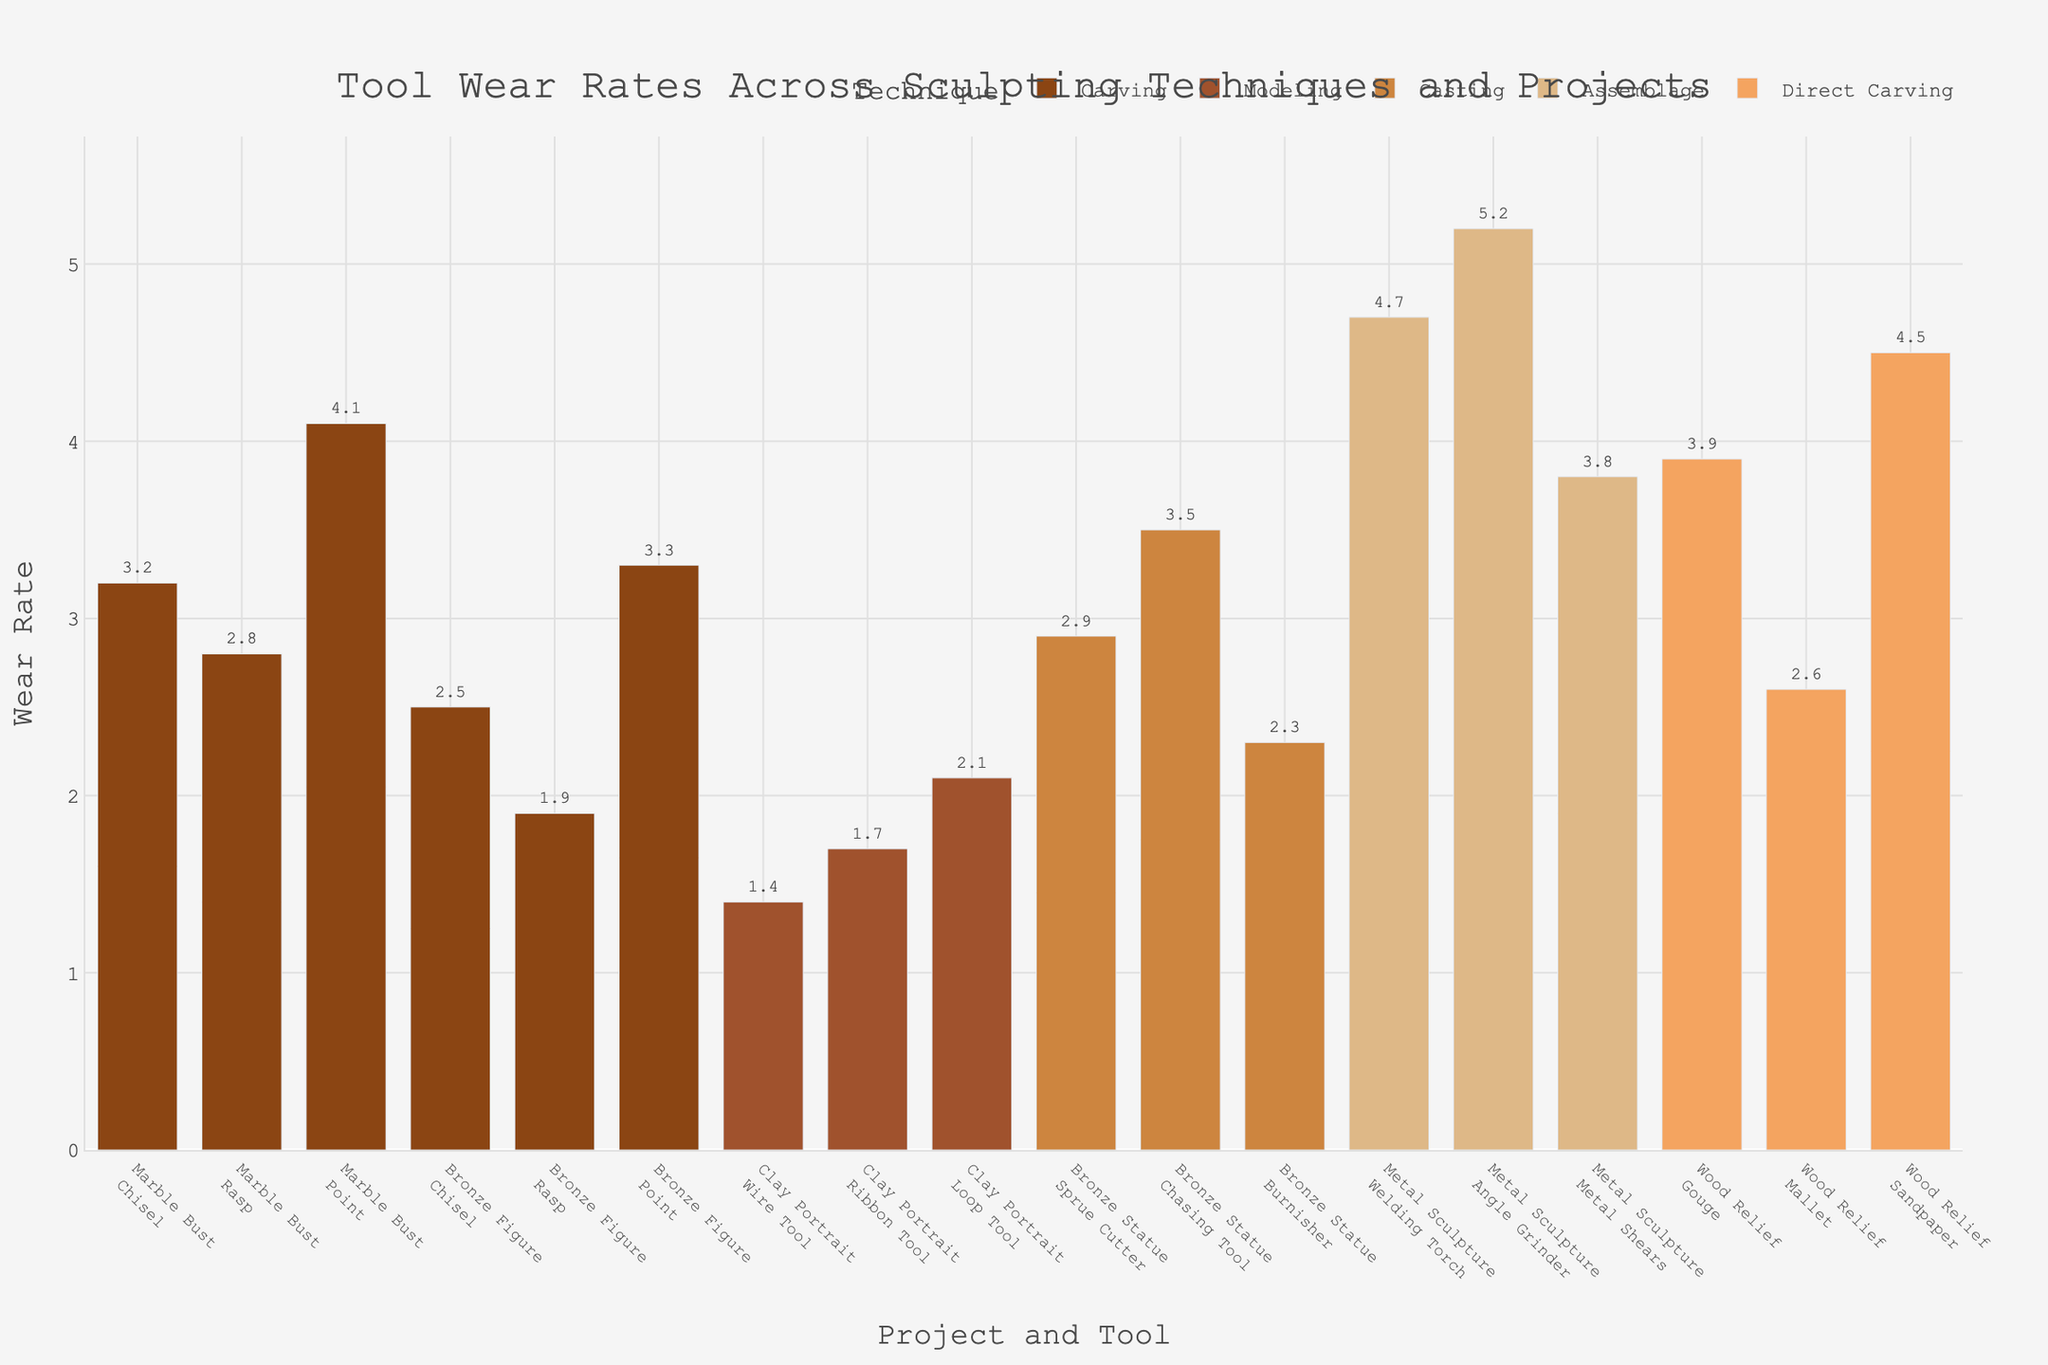What is the title of the plot? The title is displayed at the top of the plot. It reads "Tool Wear Rates Across Sculpting Techniques and Projects" with the mentioned text style attributes.
Answer: Tool Wear Rates Across Sculpting Techniques and Projects What is the wear rate of the Chisel in the Marble Bust project? The Chisel in the Marble Bust project is part of the Carving technique. According to the data, its wear rate is listed as 3.2, which is also displayed on the plot.
Answer: 3.2 Which sculpting technique has the highest tool wear rate? Among the various tools and projects displayed, the highest wear rate is shown for the Welding Torch in the Metal Sculpture project under the Assemblage technique with a wear rate of 5.2.
Answer: Assemblage How many different projects are represented in the plot? The plot groups wear rates by labels that include the project name. There are five different project names: Marble Bust, Bronze Figure, Clay Portrait, Bronze Statue, and Metal Sculpture, and Wood Relief.
Answer: 5 What is the average wear rate for the Direct Carving technique? Direct Carving includes Gouge (3.9), Mallet (2.6), and Sandpaper (4.5). The average is calculated as (3.9 + 2.6 + 4.5) / 3 = 11 / 3 = 3.67.
Answer: 3.67 Which tool shows the minimum wear rate, and what is its value? The minimum wear rate visible on the plot is 1.4 for the Wire Tool used in the Clay Portrait project under the Modeling technique.
Answer: Wire Tool, 1.4 Compare the wear rates of the Chisel tool in the Marble Bust and Bronze Figure projects. Which project shows a higher wear rate? The wear rate of the Chisel in the Marble Bust project is 3.2, while in the Bronze Figure project, it is 2.5. Therefore, the Marble Bust project shows a higher wear rate.
Answer: Marble Bust Which project has the highest average tool wear rate across all techniques? Calculate the average wear rate for each project:
Marble Bust: (3.2 + 2.8 + 4.1) / 3 = 3.37
Bronze Figure: (2.5 + 1.9 + 3.3) / 3 = 2.57
Clay Portrait: (1.4 + 1.7 + 2.1) / 3 = 1.73
Bronze Statue: (2.9 + 3.5 + 2.3) / 3 = 2.9
Metal Sculpture: (4.7 + 5.2 + 3.8) / 3 = 4.57
Wood Relief: (3.9 + 2.6 + 4.5) / 3 = 3.67
The highest average wear rate is for the Metal Sculpture project at 4.57.
Answer: Metal Sculpture What is the wear rate for the Chasing Tool in the Bronze Statue project? The wear rate for the Chasing Tool in the Bronze Statue project is listed directly on the figure as 3.5.
Answer: 3.5 How much higher is the wear rate of the Angle Grinder compared to the Metal Shears in the Metal Sculpture project? The wear rate of the Angle Grinder is 5.2, and the wear rate of the Metal Shears is 3.8. The difference is 5.2 - 3.8 = 1.4.
Answer: 1.4 